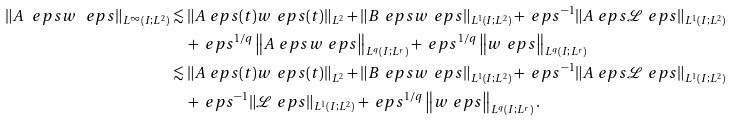Convert formula to latex. <formula><loc_0><loc_0><loc_500><loc_500>\| A ^ { \ } e p s w ^ { \ } e p s \| _ { L ^ { \infty } ( I ; L ^ { 2 } ) } & \lesssim \| A ^ { \ } e p s ( t ) w ^ { \ } e p s ( t ) \| _ { L ^ { 2 } } + \| B ^ { \ } e p s w ^ { \ } e p s \| _ { L ^ { 1 } ( I ; L ^ { 2 } ) } + \ e p s ^ { - 1 } \| A ^ { \ } e p s \mathcal { L } ^ { \ } e p s \| _ { L ^ { 1 } ( I ; L ^ { 2 } ) } \\ & \quad + \ e p s ^ { 1 / q } \left \| A ^ { \ } e p s w ^ { \ } e p s \right \| _ { L ^ { q } ( I ; L ^ { r } ) } + \ e p s ^ { 1 / q } \left \| w ^ { \ } e p s \right \| _ { L ^ { q } ( I ; L ^ { r } ) } \\ & \lesssim \| A ^ { \ } e p s ( t ) w ^ { \ } e p s ( t ) \| _ { L ^ { 2 } } + \| B ^ { \ } e p s w ^ { \ } e p s \| _ { L ^ { 1 } ( I ; L ^ { 2 } ) } + \ e p s ^ { - 1 } \| A ^ { \ } e p s \mathcal { L } ^ { \ } e p s \| _ { L ^ { 1 } ( I ; L ^ { 2 } ) } \\ & \quad + \ e p s ^ { - 1 } \| \mathcal { L } ^ { \ } e p s \| _ { L ^ { 1 } ( I ; L ^ { 2 } ) } + \ e p s ^ { 1 / q } \left \| w ^ { \ } e p s \right \| _ { L ^ { q } ( I ; L ^ { r } ) } .</formula> 